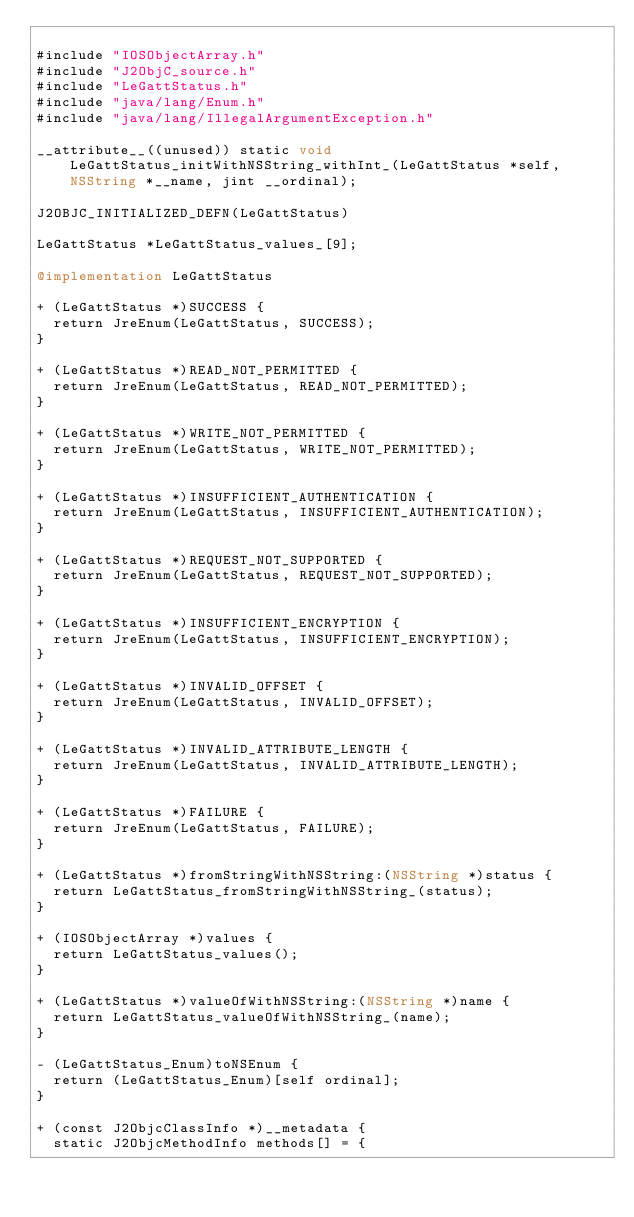Convert code to text. <code><loc_0><loc_0><loc_500><loc_500><_ObjectiveC_>
#include "IOSObjectArray.h"
#include "J2ObjC_source.h"
#include "LeGattStatus.h"
#include "java/lang/Enum.h"
#include "java/lang/IllegalArgumentException.h"

__attribute__((unused)) static void LeGattStatus_initWithNSString_withInt_(LeGattStatus *self, NSString *__name, jint __ordinal);

J2OBJC_INITIALIZED_DEFN(LeGattStatus)

LeGattStatus *LeGattStatus_values_[9];

@implementation LeGattStatus

+ (LeGattStatus *)SUCCESS {
  return JreEnum(LeGattStatus, SUCCESS);
}

+ (LeGattStatus *)READ_NOT_PERMITTED {
  return JreEnum(LeGattStatus, READ_NOT_PERMITTED);
}

+ (LeGattStatus *)WRITE_NOT_PERMITTED {
  return JreEnum(LeGattStatus, WRITE_NOT_PERMITTED);
}

+ (LeGattStatus *)INSUFFICIENT_AUTHENTICATION {
  return JreEnum(LeGattStatus, INSUFFICIENT_AUTHENTICATION);
}

+ (LeGattStatus *)REQUEST_NOT_SUPPORTED {
  return JreEnum(LeGattStatus, REQUEST_NOT_SUPPORTED);
}

+ (LeGattStatus *)INSUFFICIENT_ENCRYPTION {
  return JreEnum(LeGattStatus, INSUFFICIENT_ENCRYPTION);
}

+ (LeGattStatus *)INVALID_OFFSET {
  return JreEnum(LeGattStatus, INVALID_OFFSET);
}

+ (LeGattStatus *)INVALID_ATTRIBUTE_LENGTH {
  return JreEnum(LeGattStatus, INVALID_ATTRIBUTE_LENGTH);
}

+ (LeGattStatus *)FAILURE {
  return JreEnum(LeGattStatus, FAILURE);
}

+ (LeGattStatus *)fromStringWithNSString:(NSString *)status {
  return LeGattStatus_fromStringWithNSString_(status);
}

+ (IOSObjectArray *)values {
  return LeGattStatus_values();
}

+ (LeGattStatus *)valueOfWithNSString:(NSString *)name {
  return LeGattStatus_valueOfWithNSString_(name);
}

- (LeGattStatus_Enum)toNSEnum {
  return (LeGattStatus_Enum)[self ordinal];
}

+ (const J2ObjcClassInfo *)__metadata {
  static J2ObjcMethodInfo methods[] = {</code> 